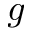<formula> <loc_0><loc_0><loc_500><loc_500>g</formula> 